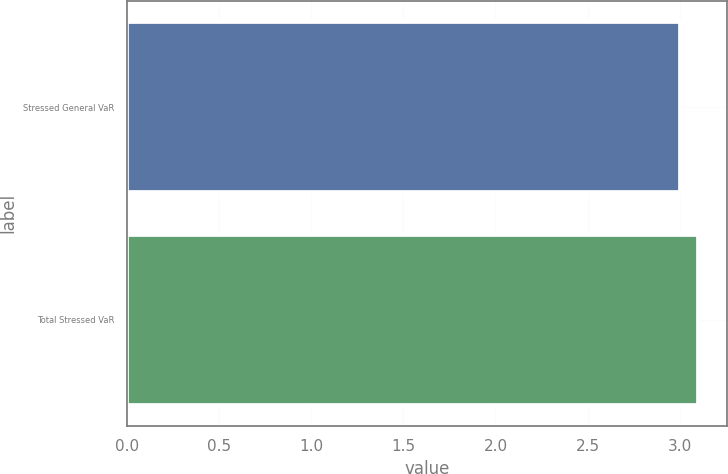Convert chart to OTSL. <chart><loc_0><loc_0><loc_500><loc_500><bar_chart><fcel>Stressed General VaR<fcel>Total Stressed VaR<nl><fcel>3<fcel>3.1<nl></chart> 